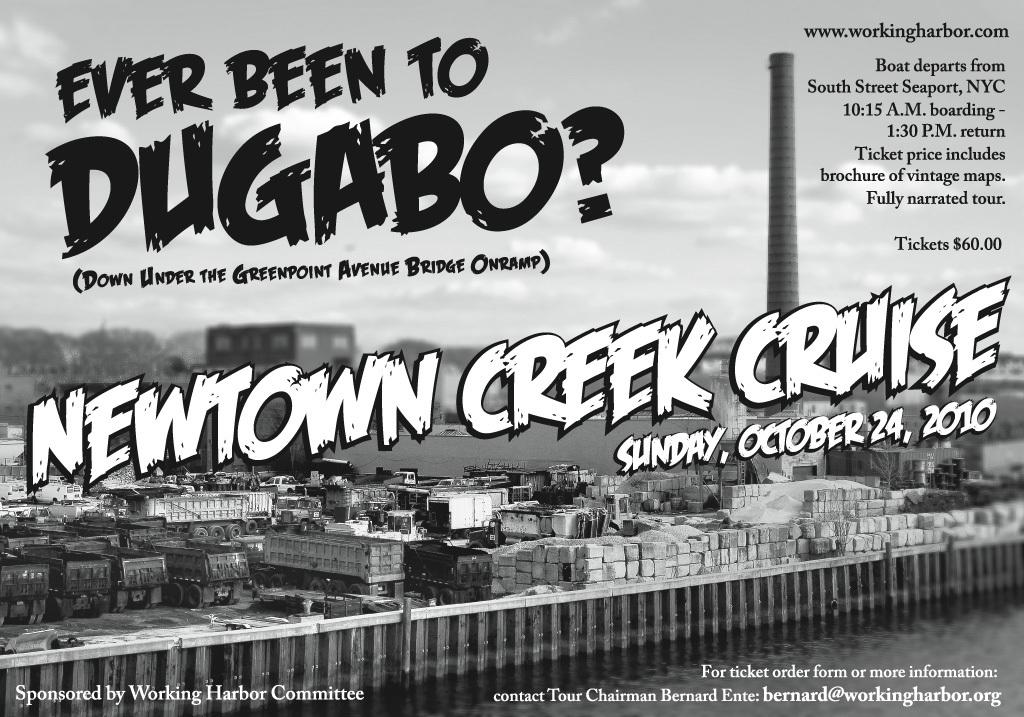<image>
Give a short and clear explanation of the subsequent image. Poster for Dugabo and a cruise which takes place on October 24th. 